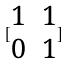Convert formula to latex. <formula><loc_0><loc_0><loc_500><loc_500>[ \begin{matrix} 1 & 1 \\ 0 & 1 \end{matrix} ]</formula> 